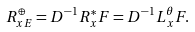Convert formula to latex. <formula><loc_0><loc_0><loc_500><loc_500>R _ { x E } ^ { \oplus } = D ^ { - 1 } R _ { x } ^ { * } F = D ^ { - 1 } L _ { x } ^ { \theta } F .</formula> 